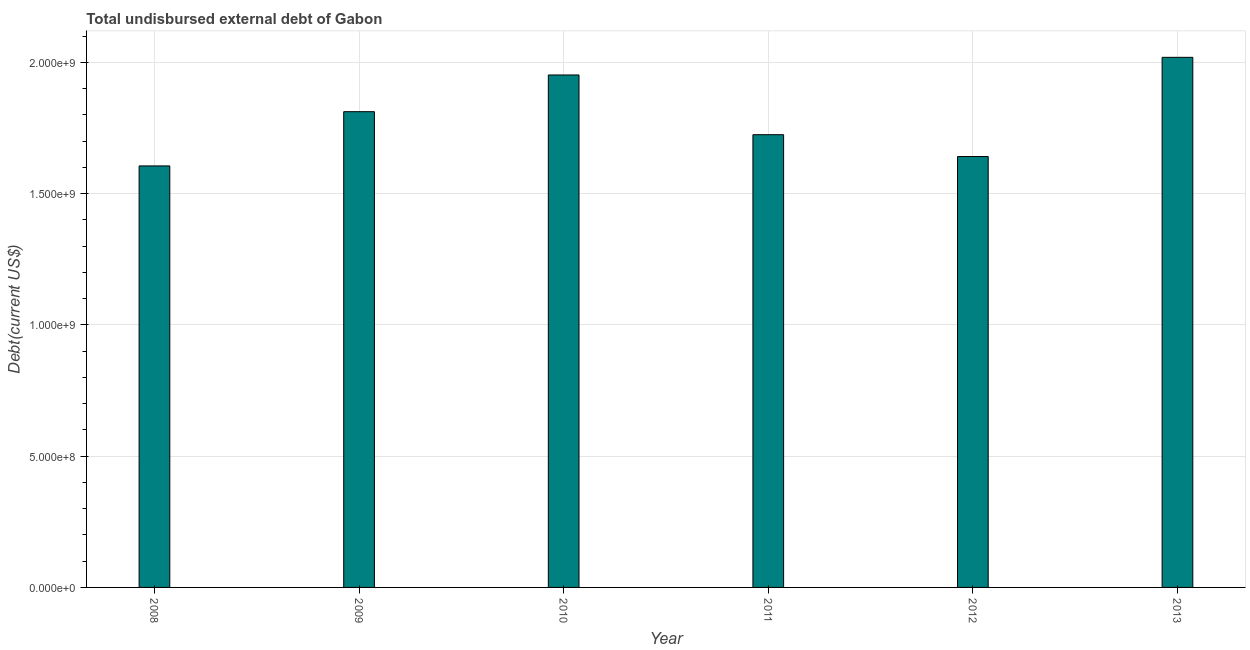What is the title of the graph?
Keep it short and to the point. Total undisbursed external debt of Gabon. What is the label or title of the Y-axis?
Ensure brevity in your answer.  Debt(current US$). What is the total debt in 2013?
Make the answer very short. 2.02e+09. Across all years, what is the maximum total debt?
Provide a short and direct response. 2.02e+09. Across all years, what is the minimum total debt?
Your answer should be compact. 1.61e+09. In which year was the total debt maximum?
Ensure brevity in your answer.  2013. In which year was the total debt minimum?
Offer a terse response. 2008. What is the sum of the total debt?
Provide a succinct answer. 1.08e+1. What is the difference between the total debt in 2009 and 2013?
Ensure brevity in your answer.  -2.07e+08. What is the average total debt per year?
Your response must be concise. 1.79e+09. What is the median total debt?
Provide a short and direct response. 1.77e+09. In how many years, is the total debt greater than 1200000000 US$?
Offer a very short reply. 6. What is the ratio of the total debt in 2012 to that in 2013?
Your response must be concise. 0.81. Is the total debt in 2008 less than that in 2012?
Your answer should be compact. Yes. What is the difference between the highest and the second highest total debt?
Offer a terse response. 6.72e+07. What is the difference between the highest and the lowest total debt?
Offer a very short reply. 4.14e+08. How many bars are there?
Provide a short and direct response. 6. Are all the bars in the graph horizontal?
Keep it short and to the point. No. Are the values on the major ticks of Y-axis written in scientific E-notation?
Provide a short and direct response. Yes. What is the Debt(current US$) of 2008?
Ensure brevity in your answer.  1.61e+09. What is the Debt(current US$) in 2009?
Ensure brevity in your answer.  1.81e+09. What is the Debt(current US$) in 2010?
Keep it short and to the point. 1.95e+09. What is the Debt(current US$) in 2011?
Your response must be concise. 1.72e+09. What is the Debt(current US$) in 2012?
Your answer should be very brief. 1.64e+09. What is the Debt(current US$) in 2013?
Keep it short and to the point. 2.02e+09. What is the difference between the Debt(current US$) in 2008 and 2009?
Offer a terse response. -2.07e+08. What is the difference between the Debt(current US$) in 2008 and 2010?
Provide a short and direct response. -3.46e+08. What is the difference between the Debt(current US$) in 2008 and 2011?
Provide a succinct answer. -1.19e+08. What is the difference between the Debt(current US$) in 2008 and 2012?
Provide a short and direct response. -3.57e+07. What is the difference between the Debt(current US$) in 2008 and 2013?
Your answer should be compact. -4.14e+08. What is the difference between the Debt(current US$) in 2009 and 2010?
Your answer should be very brief. -1.40e+08. What is the difference between the Debt(current US$) in 2009 and 2011?
Offer a very short reply. 8.77e+07. What is the difference between the Debt(current US$) in 2009 and 2012?
Provide a short and direct response. 1.71e+08. What is the difference between the Debt(current US$) in 2009 and 2013?
Your answer should be very brief. -2.07e+08. What is the difference between the Debt(current US$) in 2010 and 2011?
Offer a very short reply. 2.27e+08. What is the difference between the Debt(current US$) in 2010 and 2012?
Your answer should be compact. 3.11e+08. What is the difference between the Debt(current US$) in 2010 and 2013?
Offer a terse response. -6.72e+07. What is the difference between the Debt(current US$) in 2011 and 2012?
Your answer should be very brief. 8.32e+07. What is the difference between the Debt(current US$) in 2011 and 2013?
Make the answer very short. -2.95e+08. What is the difference between the Debt(current US$) in 2012 and 2013?
Offer a very short reply. -3.78e+08. What is the ratio of the Debt(current US$) in 2008 to that in 2009?
Ensure brevity in your answer.  0.89. What is the ratio of the Debt(current US$) in 2008 to that in 2010?
Give a very brief answer. 0.82. What is the ratio of the Debt(current US$) in 2008 to that in 2012?
Your answer should be very brief. 0.98. What is the ratio of the Debt(current US$) in 2008 to that in 2013?
Your answer should be compact. 0.8. What is the ratio of the Debt(current US$) in 2009 to that in 2010?
Give a very brief answer. 0.93. What is the ratio of the Debt(current US$) in 2009 to that in 2011?
Offer a very short reply. 1.05. What is the ratio of the Debt(current US$) in 2009 to that in 2012?
Give a very brief answer. 1.1. What is the ratio of the Debt(current US$) in 2009 to that in 2013?
Provide a short and direct response. 0.9. What is the ratio of the Debt(current US$) in 2010 to that in 2011?
Make the answer very short. 1.13. What is the ratio of the Debt(current US$) in 2010 to that in 2012?
Offer a terse response. 1.19. What is the ratio of the Debt(current US$) in 2010 to that in 2013?
Your answer should be very brief. 0.97. What is the ratio of the Debt(current US$) in 2011 to that in 2012?
Your answer should be compact. 1.05. What is the ratio of the Debt(current US$) in 2011 to that in 2013?
Make the answer very short. 0.85. What is the ratio of the Debt(current US$) in 2012 to that in 2013?
Make the answer very short. 0.81. 